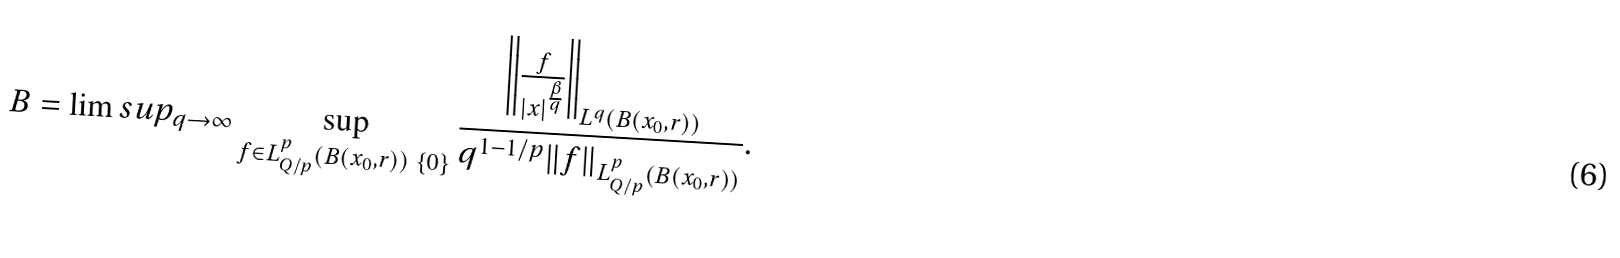<formula> <loc_0><loc_0><loc_500><loc_500>B = \lim s u p _ { q \rightarrow \infty } \sup _ { f \in L ^ { p } _ { Q / p } ( B ( x _ { 0 } , r ) ) \ \{ 0 \} } \frac { \left \| \frac { f } { | x | ^ { \frac { \beta } { q } } } \right \| _ { L ^ { q } ( B ( x _ { 0 } , r ) ) } } { q ^ { 1 - 1 / p } \| f \| _ { L ^ { p } _ { Q / p } ( B ( x _ { 0 } , r ) ) } } .</formula> 